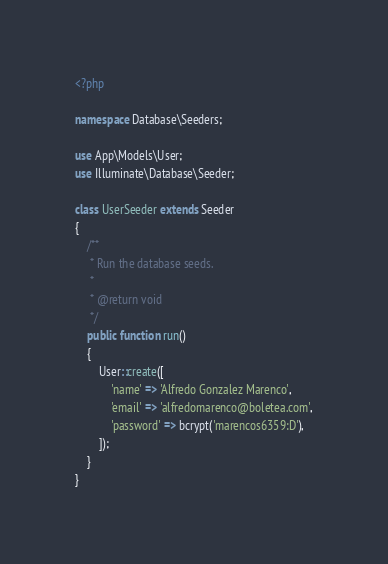Convert code to text. <code><loc_0><loc_0><loc_500><loc_500><_PHP_><?php

namespace Database\Seeders;

use App\Models\User;
use Illuminate\Database\Seeder;

class UserSeeder extends Seeder
{
    /**
     * Run the database seeds.
     *
     * @return void
     */
    public function run()
    {
        User::create([
            'name' => 'Alfredo Gonzalez Marenco',
            'email' => 'alfredomarenco@boletea.com',
            'password' => bcrypt('marencos6359:D'),
        ]);
    }
}
</code> 